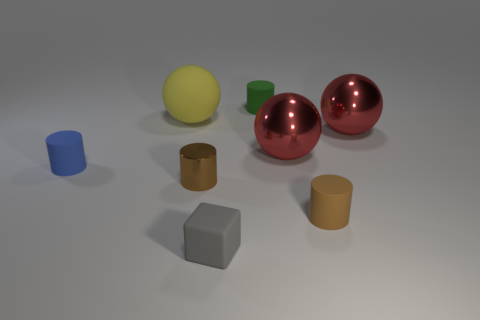Do the metal thing left of the small green rubber cylinder and the ball left of the green cylinder have the same color?
Your response must be concise. No. What is the size of the brown metal thing that is the same shape as the blue thing?
Offer a terse response. Small. Is there another small metallic cylinder of the same color as the metallic cylinder?
Offer a terse response. No. There is another cylinder that is the same color as the metal cylinder; what material is it?
Keep it short and to the point. Rubber. How many small matte cylinders are the same color as the rubber sphere?
Your answer should be very brief. 0. What number of objects are tiny matte cylinders that are right of the matte cube or tiny green cylinders?
Make the answer very short. 2. The big object that is the same material as the tiny blue cylinder is what color?
Provide a succinct answer. Yellow. Are there any red metal things of the same size as the yellow rubber ball?
Offer a terse response. Yes. How many objects are cylinders in front of the blue cylinder or cylinders behind the large rubber sphere?
Your response must be concise. 3. What shape is the brown matte thing that is the same size as the green matte cylinder?
Provide a short and direct response. Cylinder. 